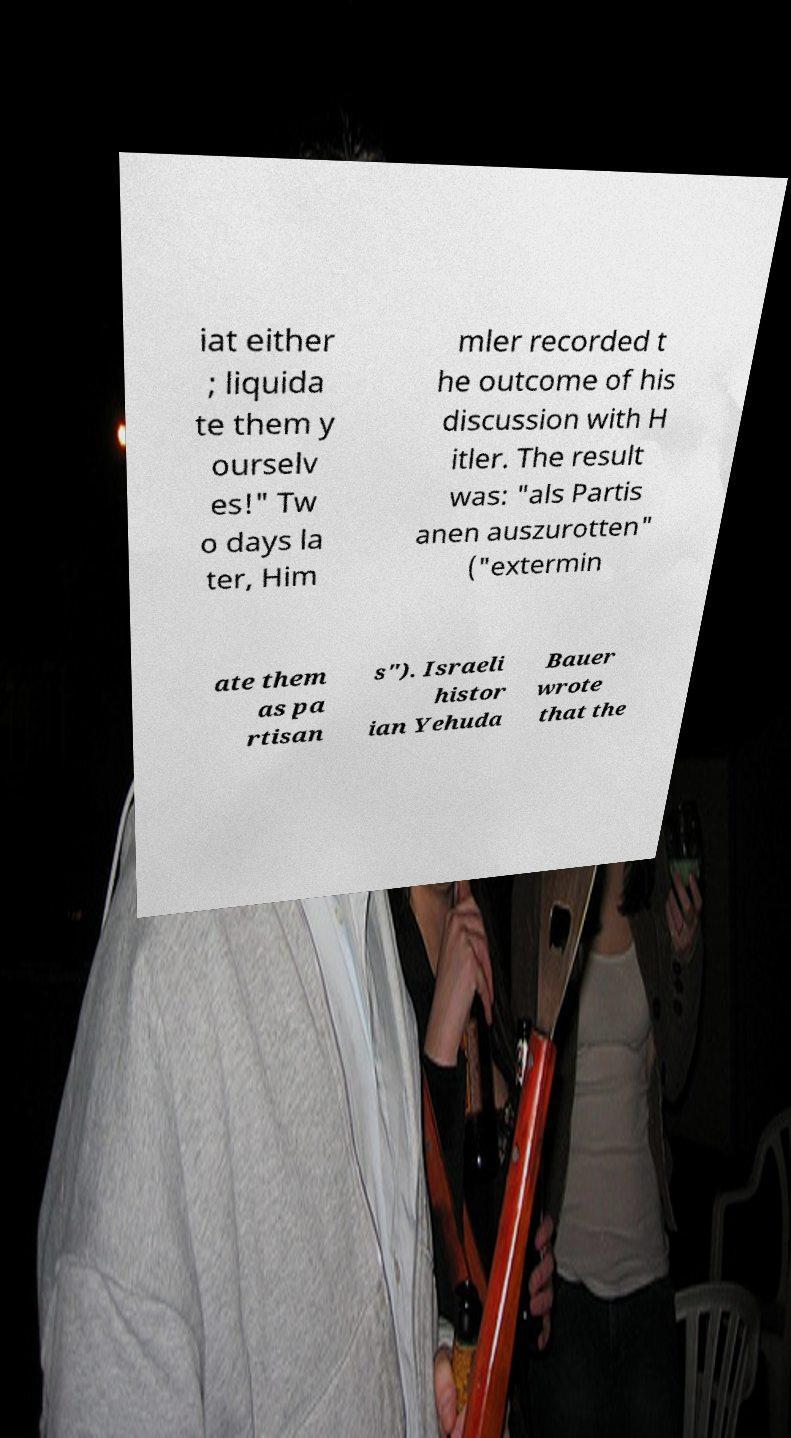Can you accurately transcribe the text from the provided image for me? iat either ; liquida te them y ourselv es!" Tw o days la ter, Him mler recorded t he outcome of his discussion with H itler. The result was: "als Partis anen auszurotten" ("extermin ate them as pa rtisan s"). Israeli histor ian Yehuda Bauer wrote that the 